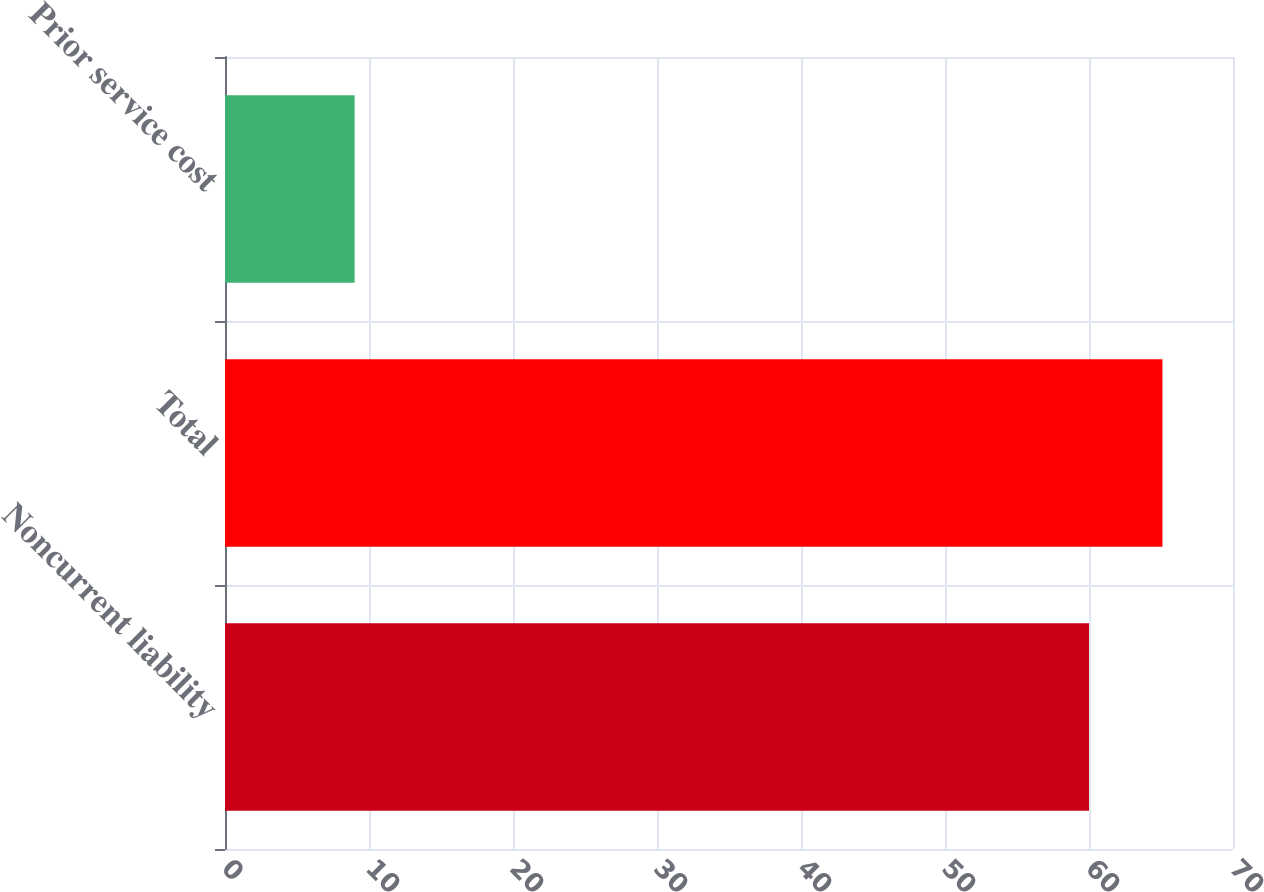<chart> <loc_0><loc_0><loc_500><loc_500><bar_chart><fcel>Noncurrent liability<fcel>Total<fcel>Prior service cost<nl><fcel>60<fcel>65.1<fcel>9<nl></chart> 